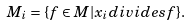<formula> <loc_0><loc_0><loc_500><loc_500>M _ { i } = \{ f \in M | x _ { i } d i v i d e s f \} .</formula> 